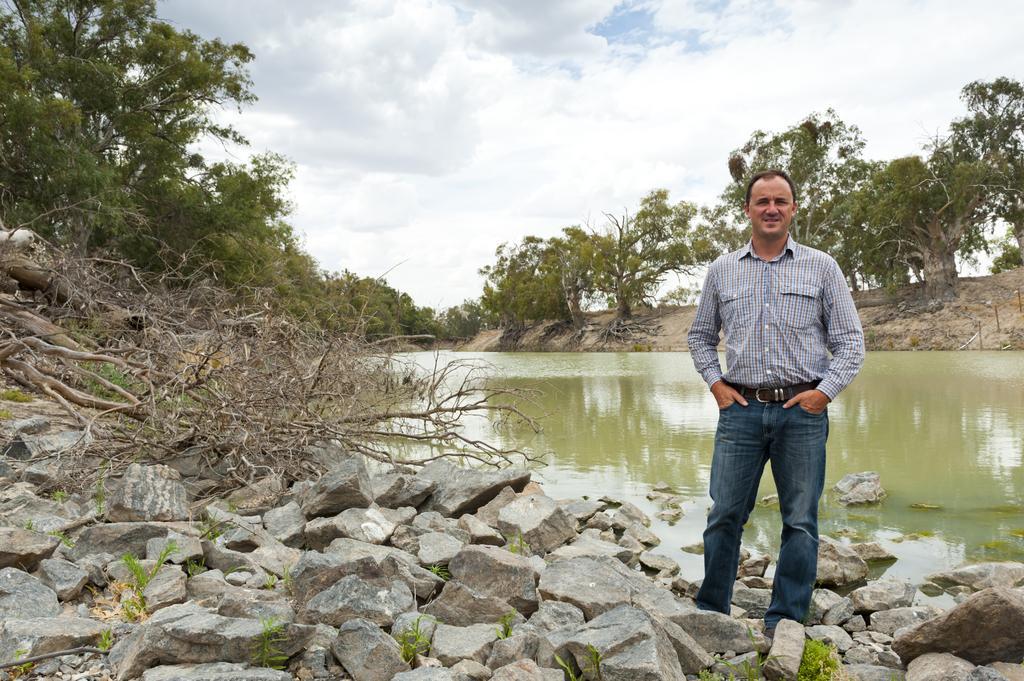Describe this image in one or two sentences. In this image there is a man standing in the middle. Behind him there is water. At the top there is the sky. On the left side there are dry sticks on the stones. In the background there are trees. 